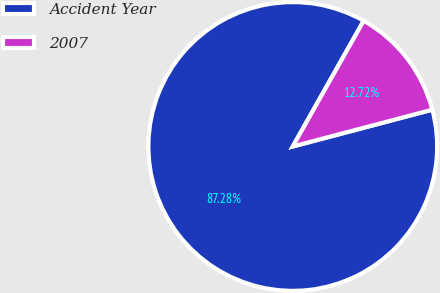<chart> <loc_0><loc_0><loc_500><loc_500><pie_chart><fcel>Accident Year<fcel>2007<nl><fcel>87.28%<fcel>12.72%<nl></chart> 